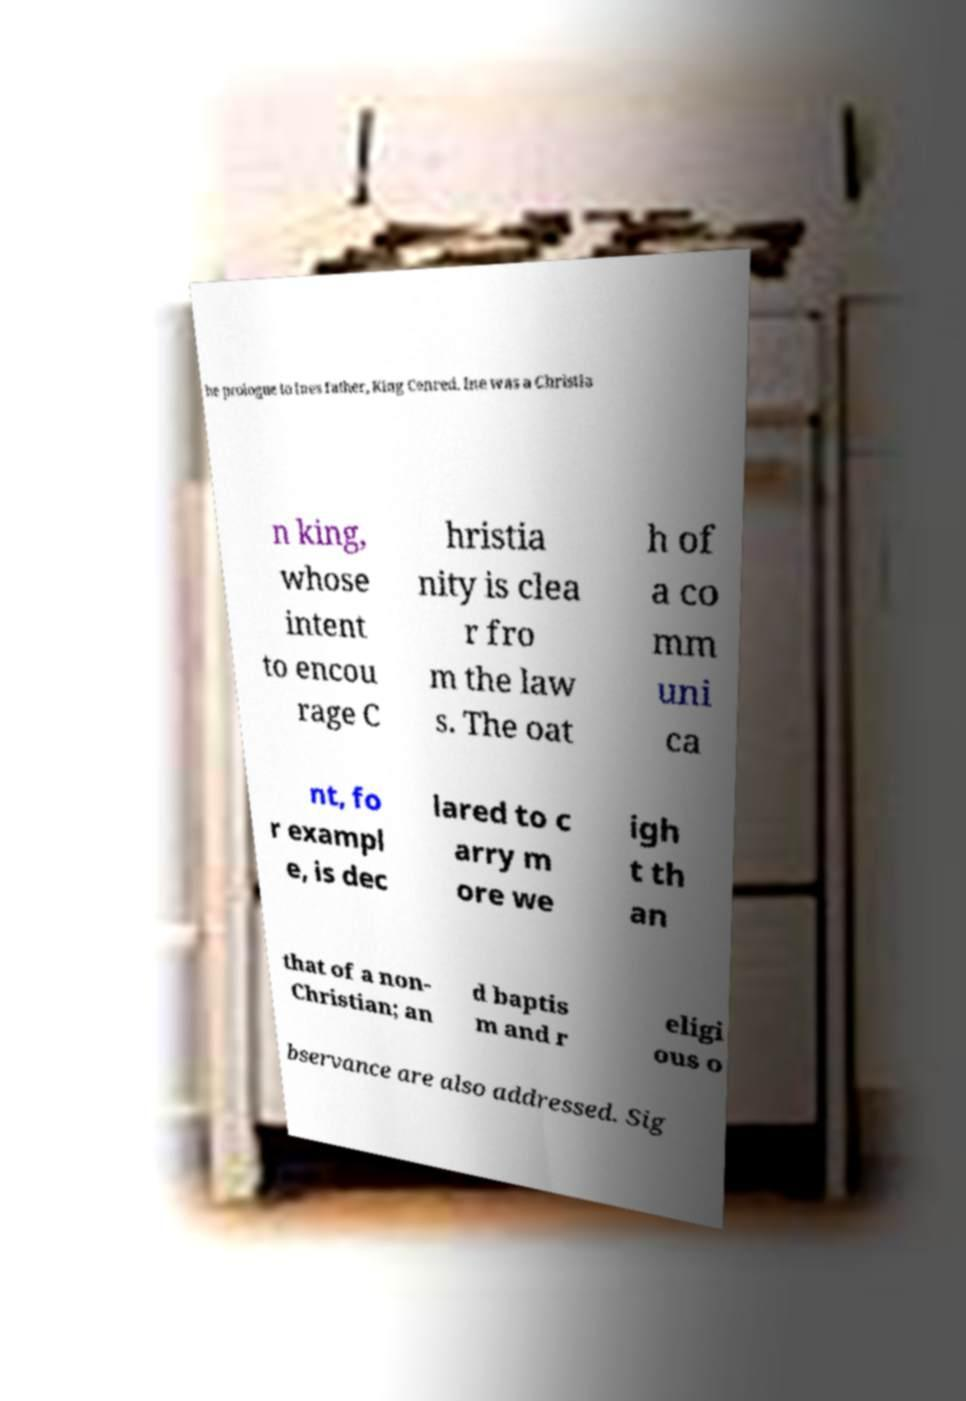Could you assist in decoding the text presented in this image and type it out clearly? he prologue to Ines father, King Cenred. Ine was a Christia n king, whose intent to encou rage C hristia nity is clea r fro m the law s. The oat h of a co mm uni ca nt, fo r exampl e, is dec lared to c arry m ore we igh t th an that of a non- Christian; an d baptis m and r eligi ous o bservance are also addressed. Sig 